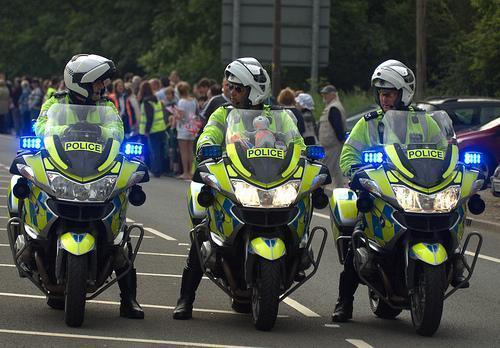How many motorcycles are there?
Give a very brief answer. 3. 